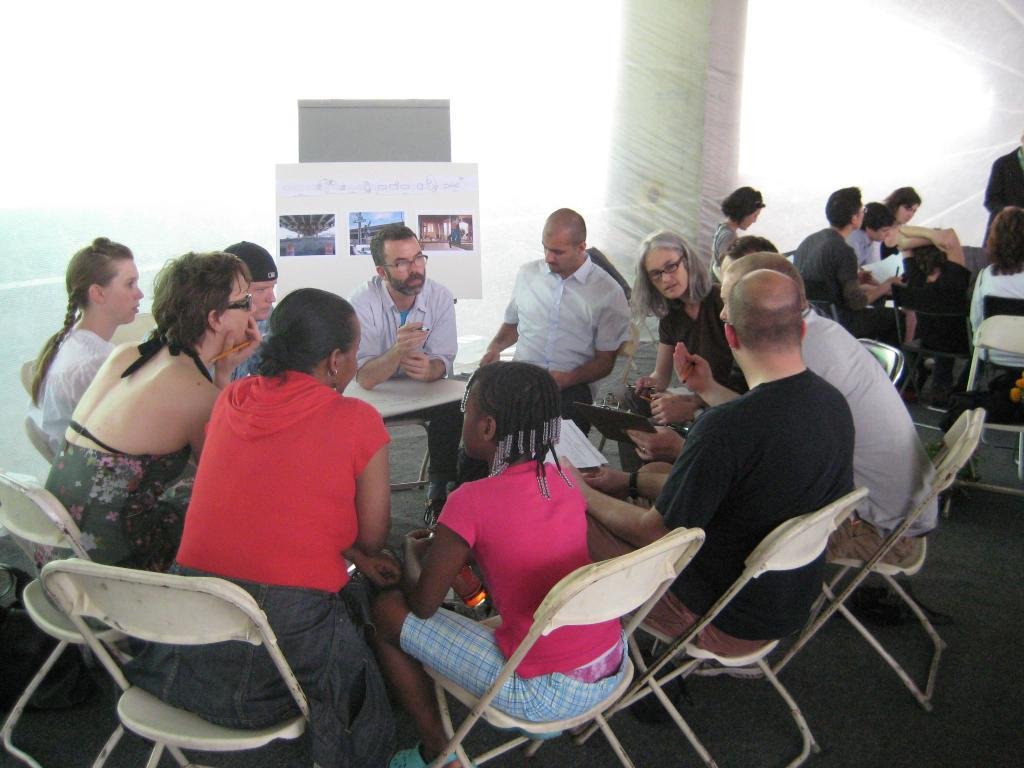How many people are in the image? There is a group of people in the image. What are the people doing in the image? The people are sitting on chairs and engaged in discussion. What can be seen in the background of the image? There is a pillar and a board in the background of the image. What is attached to the board? A poster is attached to the board. How many mice can be seen running around the chairs in the image? There are no mice present in the image; it features a group of people sitting on chairs and engaged in discussion. What type of recess is visible in the image? There is no recess present in the image; it is a group of people sitting on chairs and engaged in discussion. 